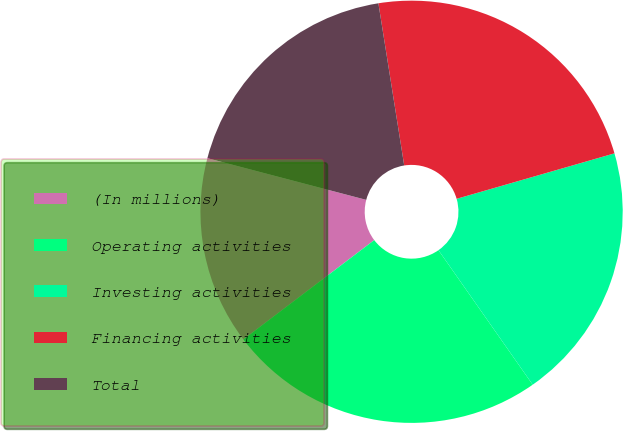<chart> <loc_0><loc_0><loc_500><loc_500><pie_chart><fcel>(In millions)<fcel>Operating activities<fcel>Investing activities<fcel>Financing activities<fcel>Total<nl><fcel>14.42%<fcel>24.39%<fcel>19.74%<fcel>23.05%<fcel>18.4%<nl></chart> 